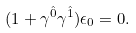Convert formula to latex. <formula><loc_0><loc_0><loc_500><loc_500>( 1 + \gamma ^ { \hat { 0 } } \gamma ^ { \hat { 1 } } ) \epsilon _ { 0 } = 0 .</formula> 